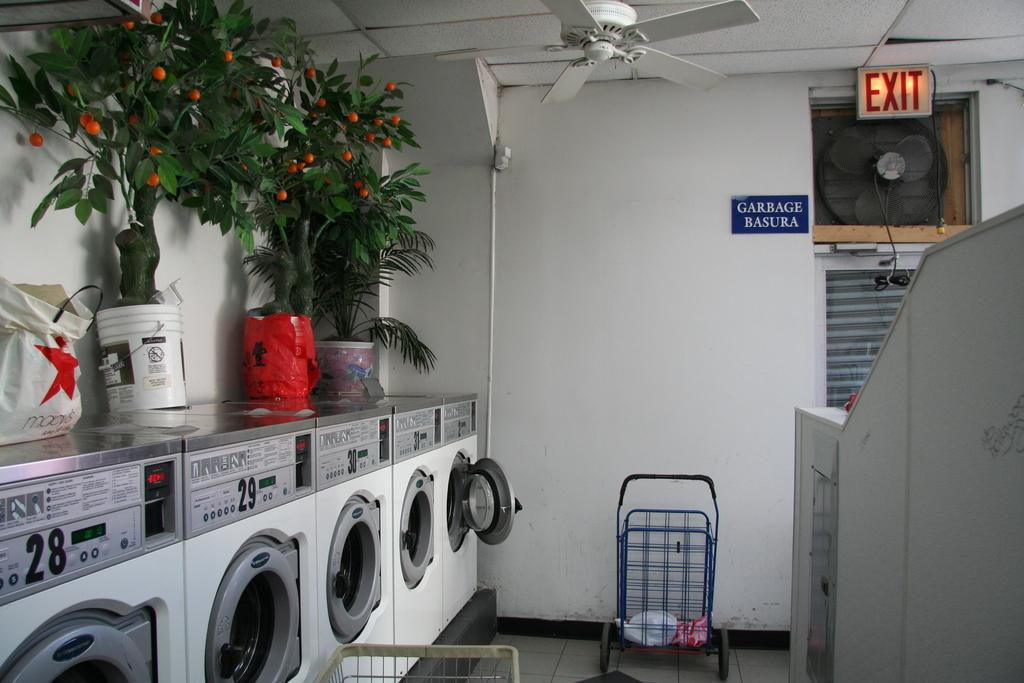Provide a one-sentence caption for the provided image. A view of the exit to the of a wall of dryers in a public laundromat. 